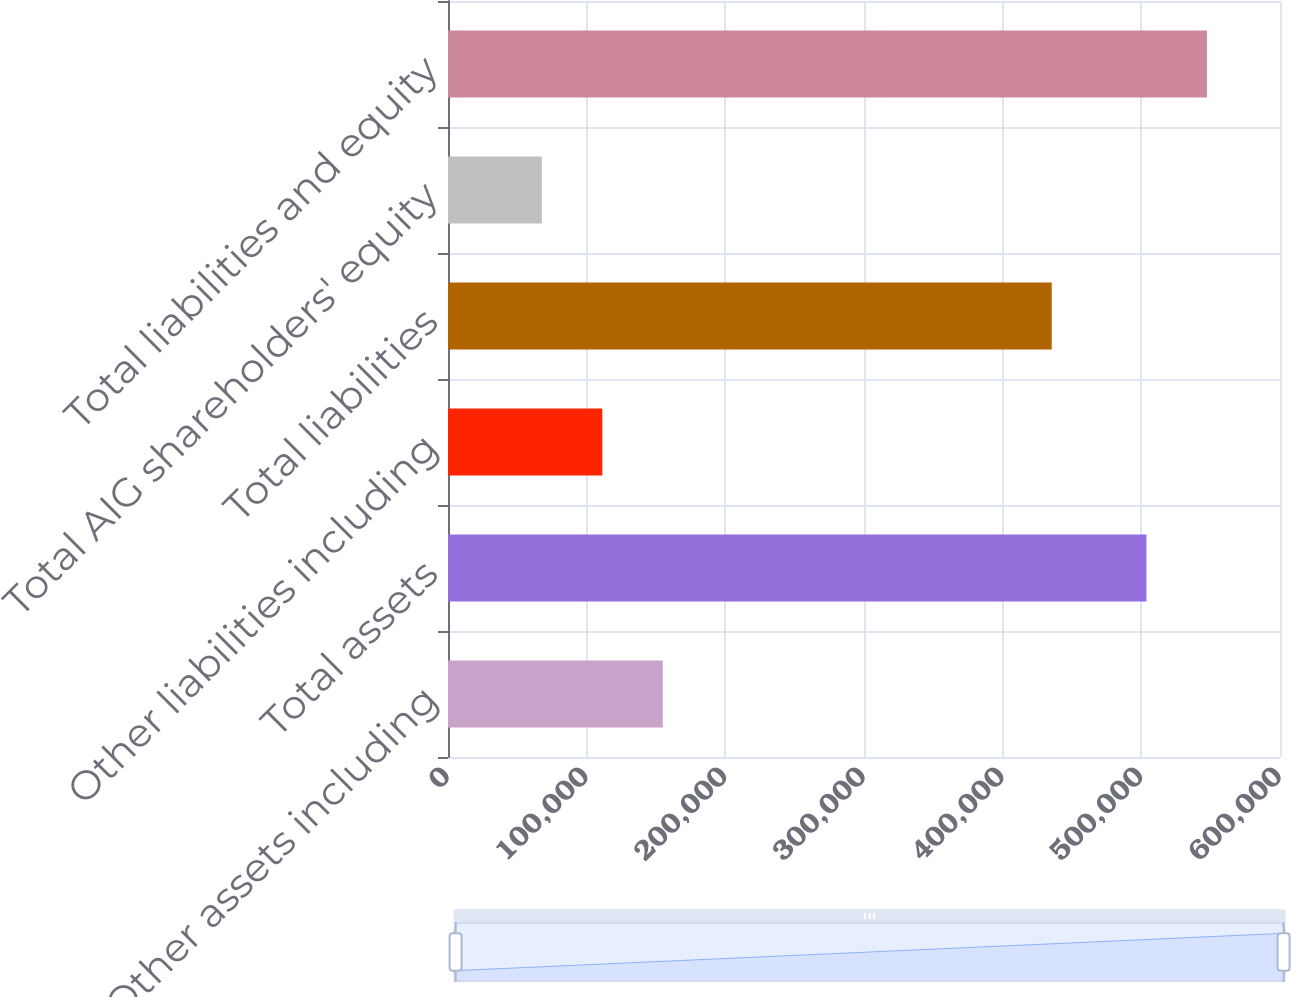<chart> <loc_0><loc_0><loc_500><loc_500><bar_chart><fcel>Other assets including<fcel>Total assets<fcel>Other liabilities including<fcel>Total liabilities<fcel>Total AIG shareholders' equity<fcel>Total liabilities and equity<nl><fcel>154877<fcel>503696<fcel>111274<fcel>435383<fcel>67672<fcel>547298<nl></chart> 